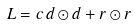<formula> <loc_0><loc_0><loc_500><loc_500>L = c \, d \odot d + r \odot r</formula> 